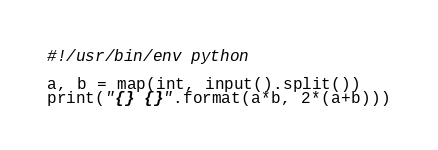<code> <loc_0><loc_0><loc_500><loc_500><_Python_>#!/usr/bin/env python

a, b = map(int, input().split())
print("{} {}".format(a*b, 2*(a+b)))
</code> 